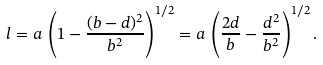<formula> <loc_0><loc_0><loc_500><loc_500>l = a \, \left ( 1 - \frac { ( b - d ) ^ { 2 } } { b ^ { 2 } } \right ) ^ { 1 / 2 } = a \, \left ( \frac { 2 d } { b } - \frac { d ^ { 2 } } { b ^ { 2 } } \right ) ^ { 1 / 2 } .</formula> 